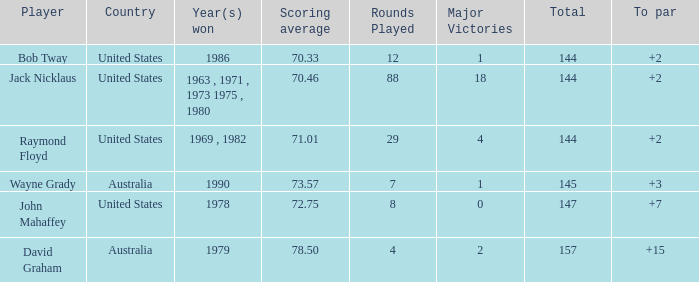What was the average round score of the player who won in 1978? 147.0. 